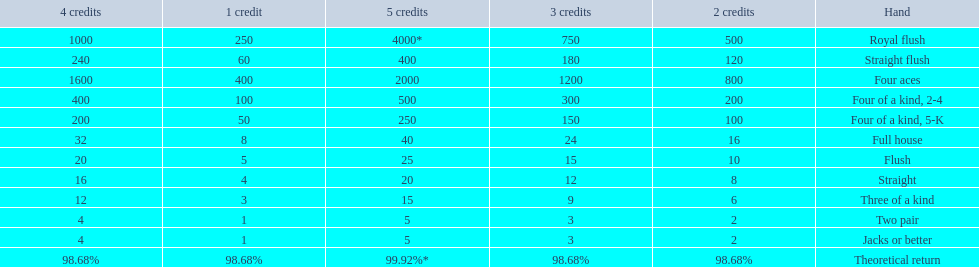What are the different hands? Royal flush, Straight flush, Four aces, Four of a kind, 2-4, Four of a kind, 5-K, Full house, Flush, Straight, Three of a kind, Two pair, Jacks or better. Which hands have a higher standing than a straight? Royal flush, Straight flush, Four aces, Four of a kind, 2-4, Four of a kind, 5-K, Full house, Flush. Of these, which hand is the next highest after a straight? Flush. 